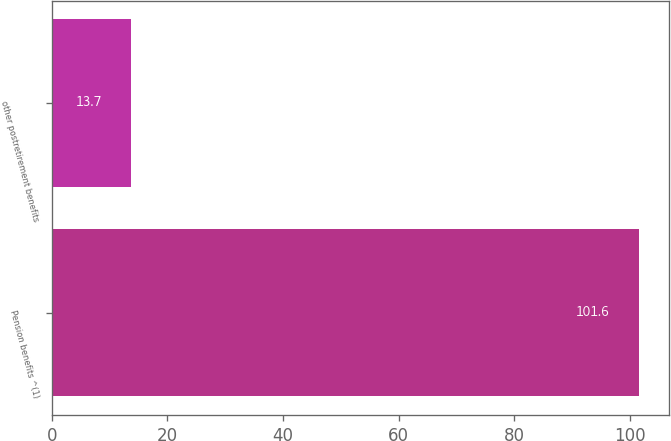Convert chart. <chart><loc_0><loc_0><loc_500><loc_500><bar_chart><fcel>Pension benefits ^(1)<fcel>other postretirement benefits<nl><fcel>101.6<fcel>13.7<nl></chart> 